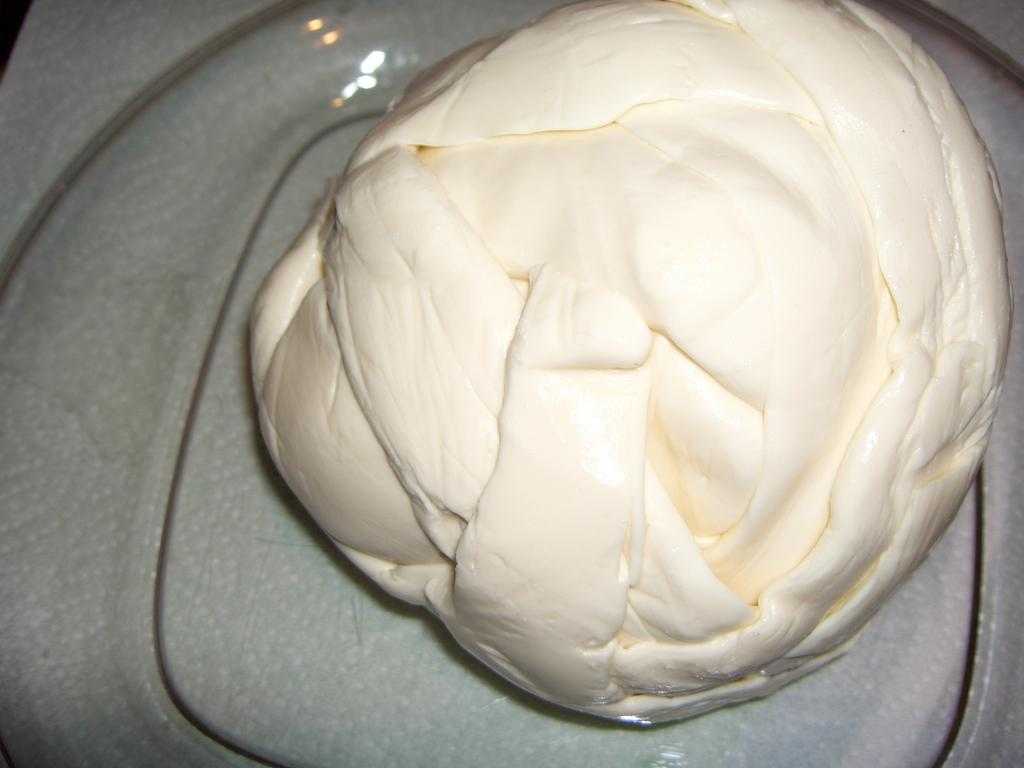What is on the plate that is visible in the image? There is a food item on a plate in the image. Where is the plate located in the image? The plate is on an object in the image. What type of milk is being poured onto the food item in the image? There is no milk present in the image, and no action of pouring is depicted. Can you see any socks in the image? There are no socks present in the image. 